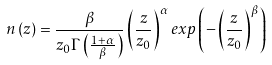Convert formula to latex. <formula><loc_0><loc_0><loc_500><loc_500>n \left ( z \right ) = \frac { \beta } { z _ { 0 } \Gamma \left ( \frac { 1 + \alpha } { \beta } \right ) } \left ( \frac { z } { z _ { 0 } } \right ) ^ { \alpha } e x p \left ( - \left ( \frac { z } { z _ { 0 } } \right ) ^ { \beta } \right )</formula> 